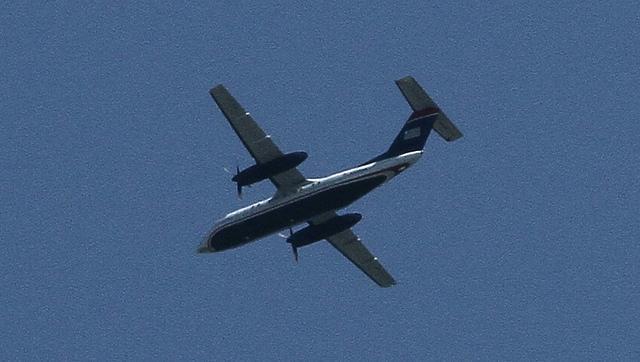How many propeller vehicles?
Give a very brief answer. 1. How many people do you see holding pizza?
Give a very brief answer. 0. 